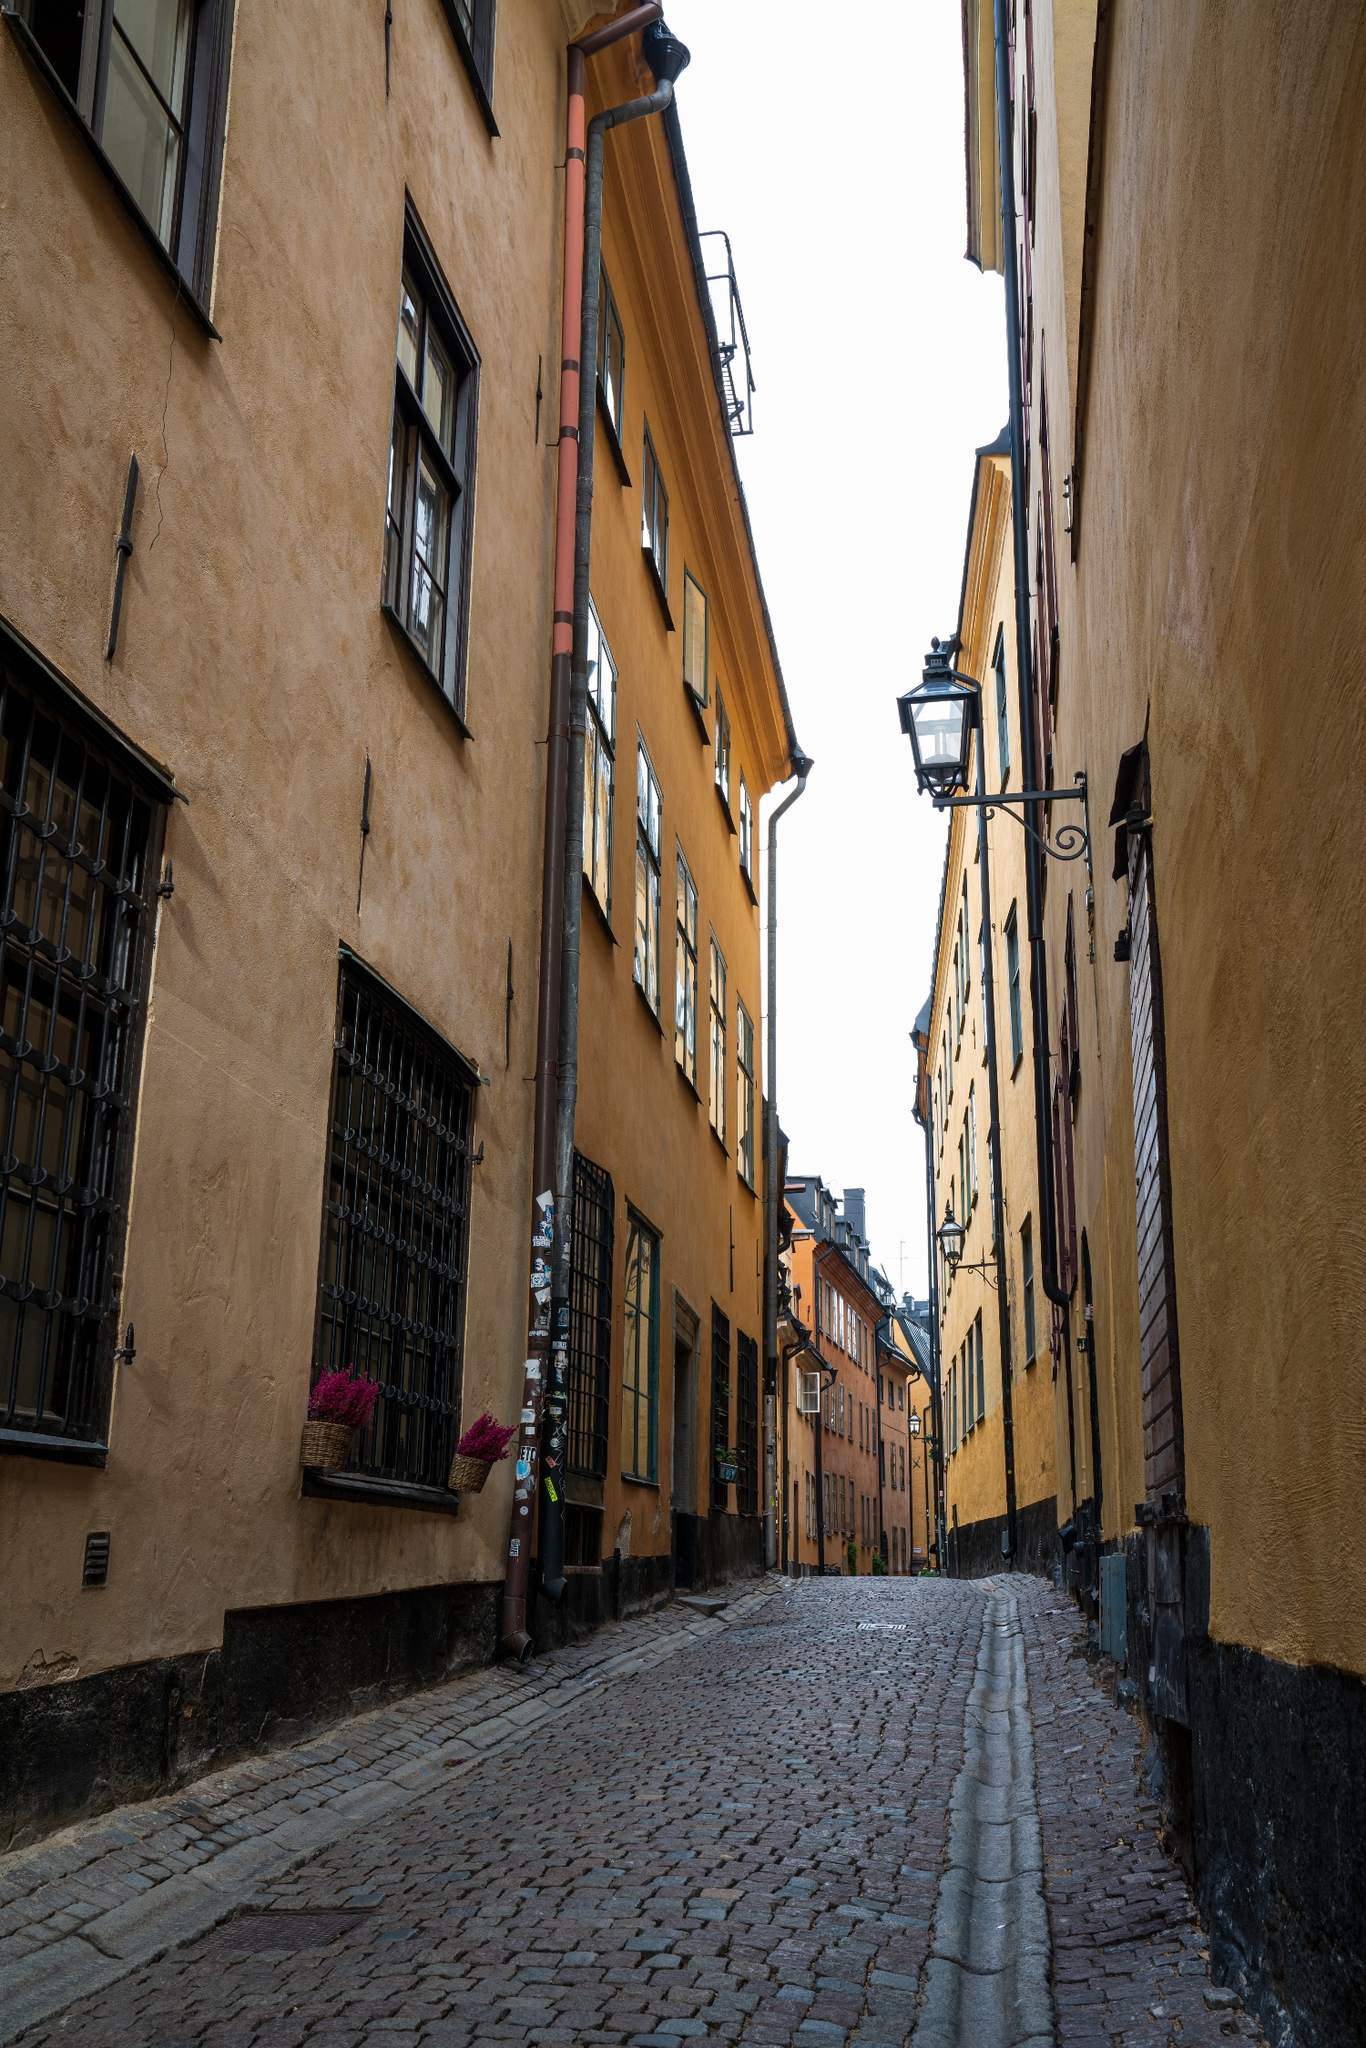Can you discuss the architectural styles visible in this picture? The architecture in the image showcases typical northern European features, characterized by steeply pitched roofs, muted yet warm facade colors and the use of durable materials like brick or stone, which are ideal for colder climates. The presence of shutters and delicate ironwork also adds to the aesthetic flair, giving the buildings a functional yet stylish appearance that is both traditional and timeless. 